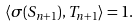<formula> <loc_0><loc_0><loc_500><loc_500>\langle \sigma ( S _ { n + 1 } ) , T _ { n + 1 } \rangle = 1 .</formula> 